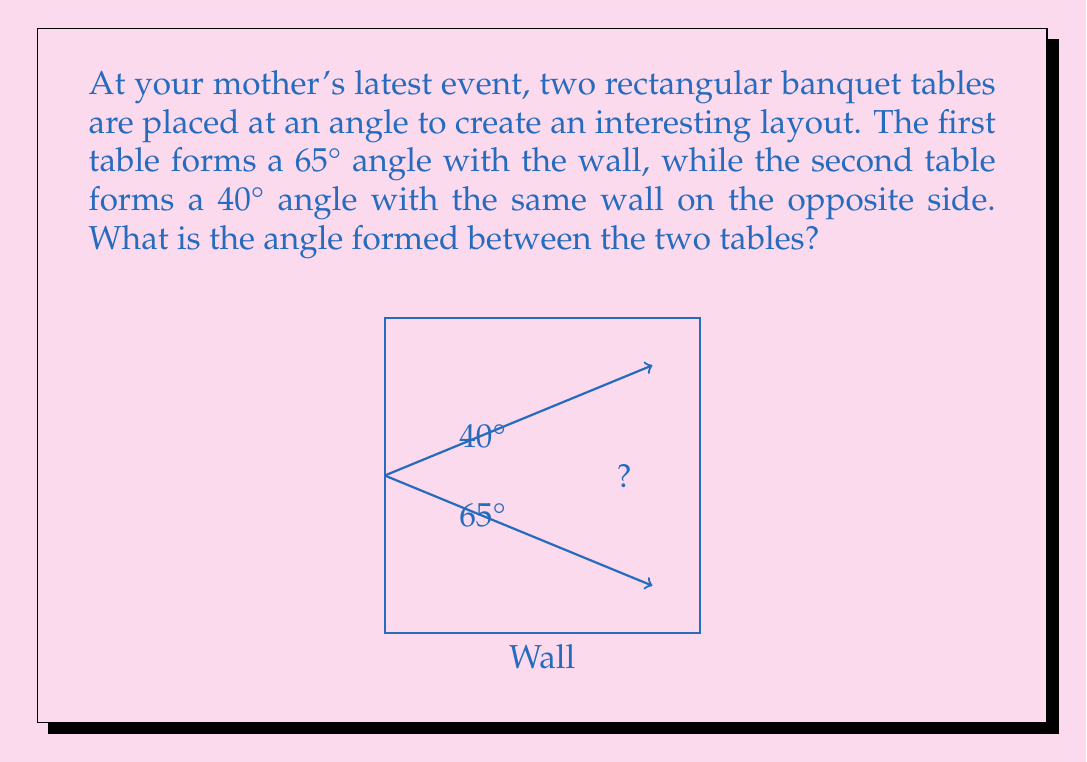Solve this math problem. Let's approach this step-by-step:

1) First, we need to understand what the question is asking. We're looking for the angle between the two tables.

2) We're given two angles: 65° (the angle between the first table and the wall) and 40° (the angle between the second table and the wall).

3) To find the angle between the tables, we need to use the concept of supplementary angles. The total angle in a straight line is 180°.

4) Let's call the angle we're looking for $x$. This angle, combined with the two given angles, should form a straight line:

   $$ 65° + 40° + x = 180° $$

5) Now we can solve for $x$:

   $$ 105° + x = 180° $$
   $$ x = 180° - 105° $$
   $$ x = 75° $$

6) Therefore, the angle between the two tables is 75°.
Answer: 75° 